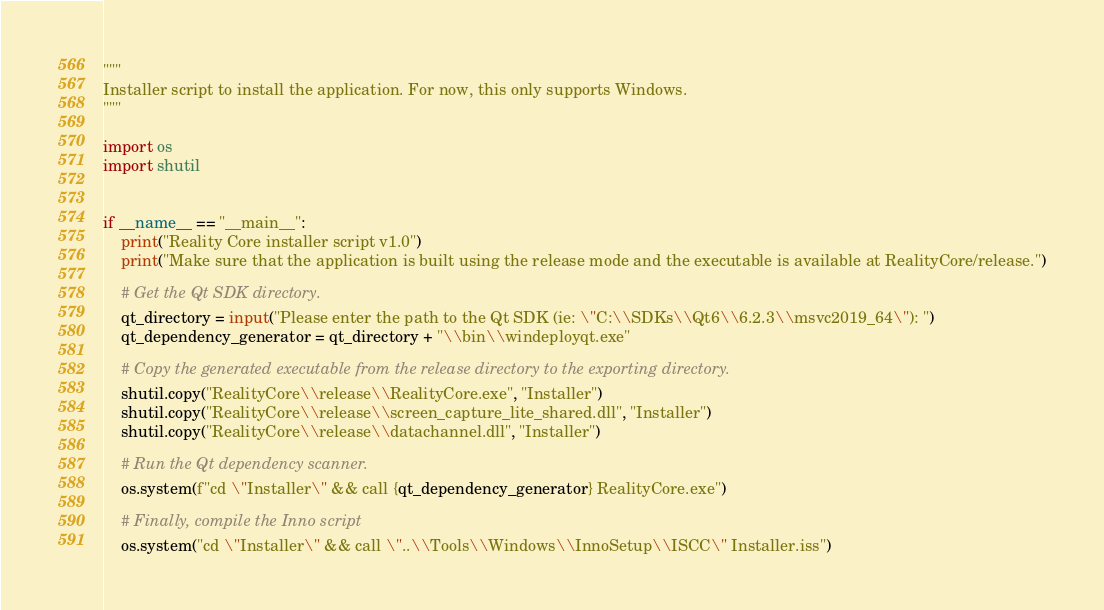Convert code to text. <code><loc_0><loc_0><loc_500><loc_500><_Python_>"""
Installer script to install the application. For now, this only supports Windows.
"""

import os
import shutil


if __name__ == "__main__":
    print("Reality Core installer script v1.0")
    print("Make sure that the application is built using the release mode and the executable is available at RealityCore/release.")

    # Get the Qt SDK directory.
    qt_directory = input("Please enter the path to the Qt SDK (ie: \"C:\\SDKs\\Qt6\\6.2.3\\msvc2019_64\"): ")
    qt_dependency_generator = qt_directory + "\\bin\\windeployqt.exe"

    # Copy the generated executable from the release directory to the exporting directory.
    shutil.copy("RealityCore\\release\\RealityCore.exe", "Installer")
    shutil.copy("RealityCore\\release\\screen_capture_lite_shared.dll", "Installer")
    shutil.copy("RealityCore\\release\\datachannel.dll", "Installer")

    # Run the Qt dependency scanner.
    os.system(f"cd \"Installer\" && call {qt_dependency_generator} RealityCore.exe")

    # Finally, compile the Inno script
    os.system("cd \"Installer\" && call \"..\\Tools\\Windows\\InnoSetup\\ISCC\" Installer.iss")
</code> 